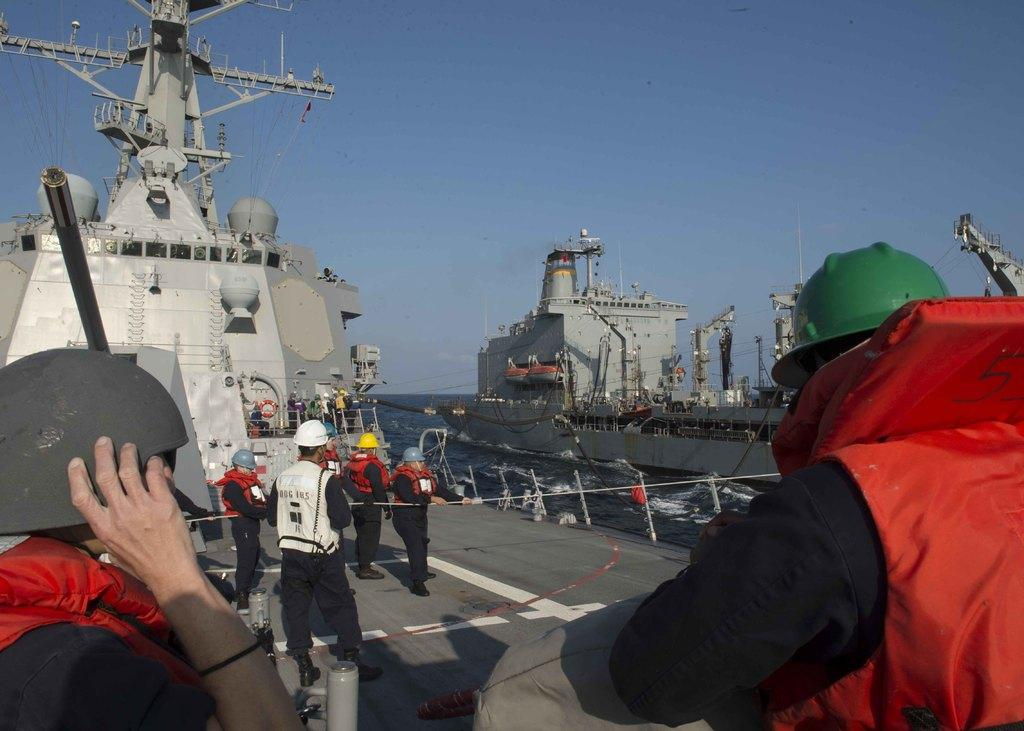Who can be seen in the foreground of the image? There are two people in the foreground of the image. What is visible in the background of the image? There is a ship and the sky visible in the background of the image. How does the guide lead the crowd in the image? There is no guide or crowd present in the image; it only features two people and a ship in the background. 